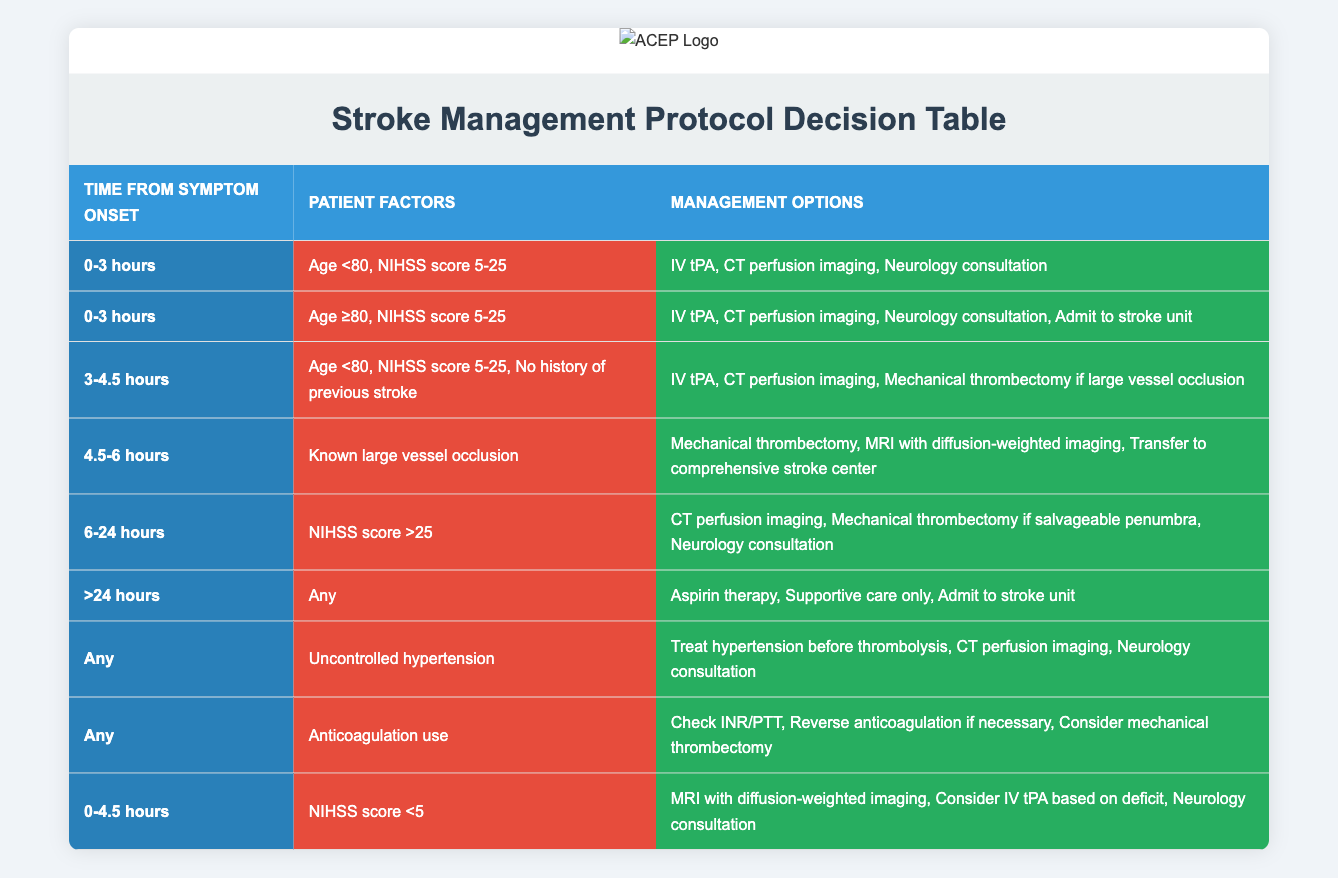What management options are available for patients with a NIHSS score greater than 25 and symptom onset between 6-24 hours? According to the table, for patients with a NIHSS score greater than 25 and symptom onset between 6-24 hours, the management options include CT perfusion imaging, mechanical thrombectomy if salvageable penumbra, and neurology consultation.
Answer: CT perfusion imaging, mechanical thrombectomy if salvageable penumbra, neurology consultation Is IV tPA an option for patients aged 80 or older with a NIHSS score of 5-25 and symptom onset within 3 hours? Yes, the table indicates that IV tPA is among the management options for patients aged 80 or older with a NIHSS score of 5-25 and symptom onset within 3 hours.
Answer: Yes Which management options are recommended for patients who have uncontrolled hypertension? The table states that for patients with uncontrolled hypertension at any time since symptom onset, the management options include treating hypertension before thrombolysis, CT perfusion imaging, and neurology consultation.
Answer: Treat hypertension before thrombolysis, CT perfusion imaging, neurology consultation How many management options are suggested for a patient with a known large vessel occlusion and symptom onset between 4.5-6 hours? For a known large vessel occlusion with symptom onset between 4.5-6 hours, the table lists three management options: mechanical thrombectomy, MRI with diffusion-weighted imaging, and transfer to a comprehensive stroke center. Therefore, the count of management options is 3.
Answer: 3 Is supportive care a management option for patients with symptom onset greater than 24 hours? Yes, the table shows that supportive care only is one of the management options for patients with symptom onset greater than 24 hours, along with aspirin therapy and admit to stroke unit.
Answer: Yes What is the difference in management options between NIHSS score less than 5 and NIHSS score between 5-25 for patients aged less than 80 with symptom onset within 3 hours? For NIHSS score less than 5, the management options are MRI with diffusion-weighted imaging, consider IV tPA based on deficit, and neurology consultation. In contrast, for NIHSS score between 5-25, the options are IV tPA, CT perfusion imaging, and neurology consultation. The difference is that the first has MRI and does not include IV tPA as a certainty, whereas the second explicitly includes IV tPA.
Answer: Different management options exist for both scores, notably the inclusion of certain procedures for the higher NIHSS group If a patient is anticoagulated, what are the three management steps included in the table? The table indicates that for patients who are anticoagulated, the management steps include checking INR/PTT, reversing anticoagulation if necessary, and considering mechanical thrombectomy.
Answer: Check INR/PTT, reverse anticoagulation if necessary, consider mechanical thrombectomy Is mechanical thrombectomy an option for patients with a history of previous stroke? No, the decision table does not list mechanical thrombectomy as a management option for patients with a history of previous stroke in any of the specified time frames.
Answer: No 